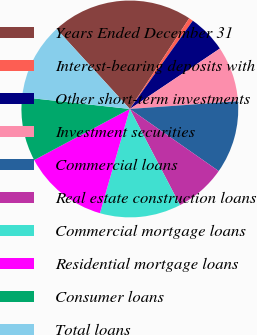Convert chart to OTSL. <chart><loc_0><loc_0><loc_500><loc_500><pie_chart><fcel>Years Ended December 31<fcel>Interest-bearing deposits with<fcel>Other short-term investments<fcel>Investment securities<fcel>Commercial loans<fcel>Real estate construction loans<fcel>Commercial mortgage loans<fcel>Residential mortgage loans<fcel>Consumer loans<fcel>Total loans<nl><fcel>21.02%<fcel>0.64%<fcel>5.73%<fcel>8.28%<fcel>10.83%<fcel>7.64%<fcel>12.1%<fcel>12.74%<fcel>9.55%<fcel>11.46%<nl></chart> 